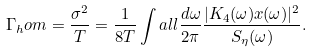<formula> <loc_0><loc_0><loc_500><loc_500>\Gamma _ { h } o m & = \frac { \sigma ^ { 2 } } { T } = \frac { 1 } { 8 T } \int a l l \frac { d \omega } { 2 \pi } \frac { | K _ { 4 } ( \omega ) x ( \omega ) | ^ { 2 } } { S _ { \eta } ( \omega ) } .</formula> 